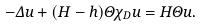Convert formula to latex. <formula><loc_0><loc_0><loc_500><loc_500>- \Delta u + ( H - h ) \Theta \chi _ { D } u = H \Theta u .</formula> 